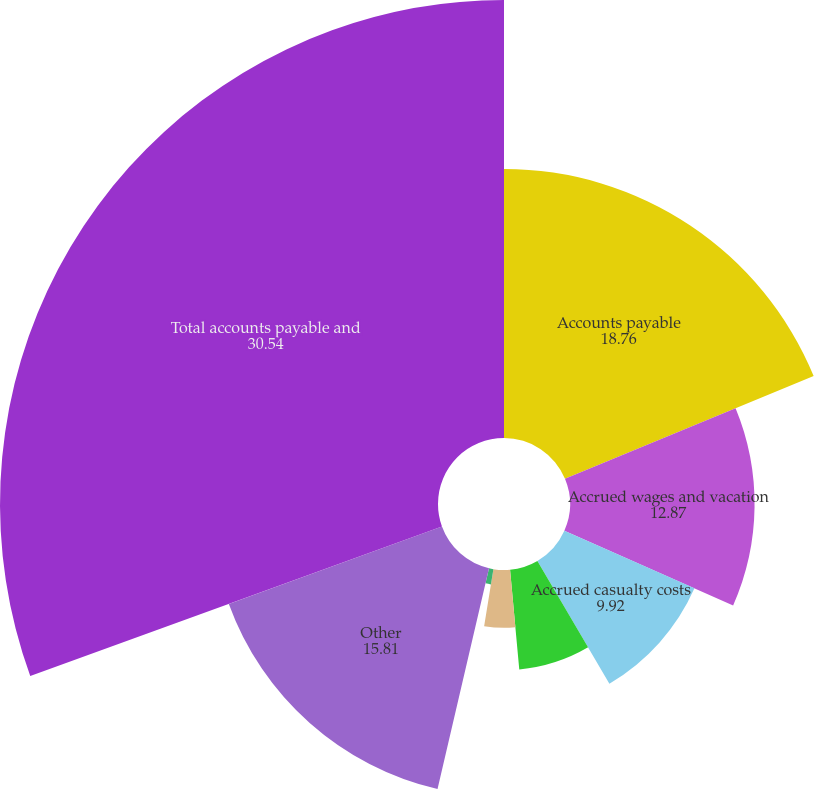Convert chart to OTSL. <chart><loc_0><loc_0><loc_500><loc_500><pie_chart><fcel>Accounts payable<fcel>Accrued wages and vacation<fcel>Accrued casualty costs<fcel>Income and other taxes<fcel>Dividends and interest<fcel>Equipment rents payable<fcel>Other<fcel>Total accounts payable and<nl><fcel>18.76%<fcel>12.87%<fcel>9.92%<fcel>6.98%<fcel>4.03%<fcel>1.08%<fcel>15.81%<fcel>30.54%<nl></chart> 